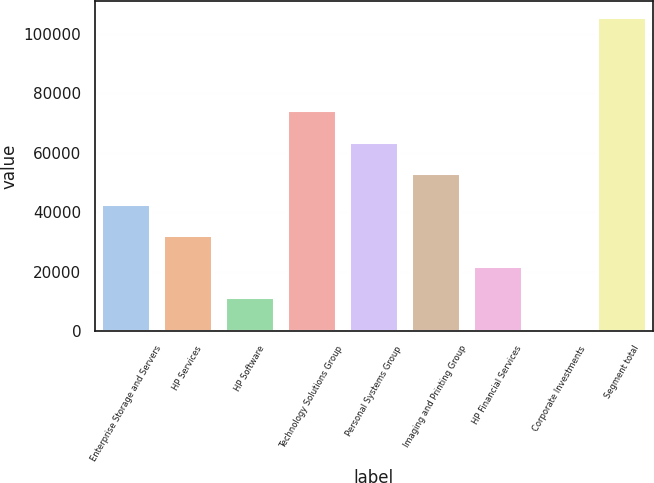Convert chart to OTSL. <chart><loc_0><loc_0><loc_500><loc_500><bar_chart><fcel>Enterprise Storage and Servers<fcel>HP Services<fcel>HP Software<fcel>Technology Solutions Group<fcel>Personal Systems Group<fcel>Imaging and Printing Group<fcel>HP Financial Services<fcel>Corporate Investments<fcel>Segment total<nl><fcel>42742<fcel>32247<fcel>11257<fcel>74227<fcel>63732<fcel>53237<fcel>21752<fcel>762<fcel>105712<nl></chart> 